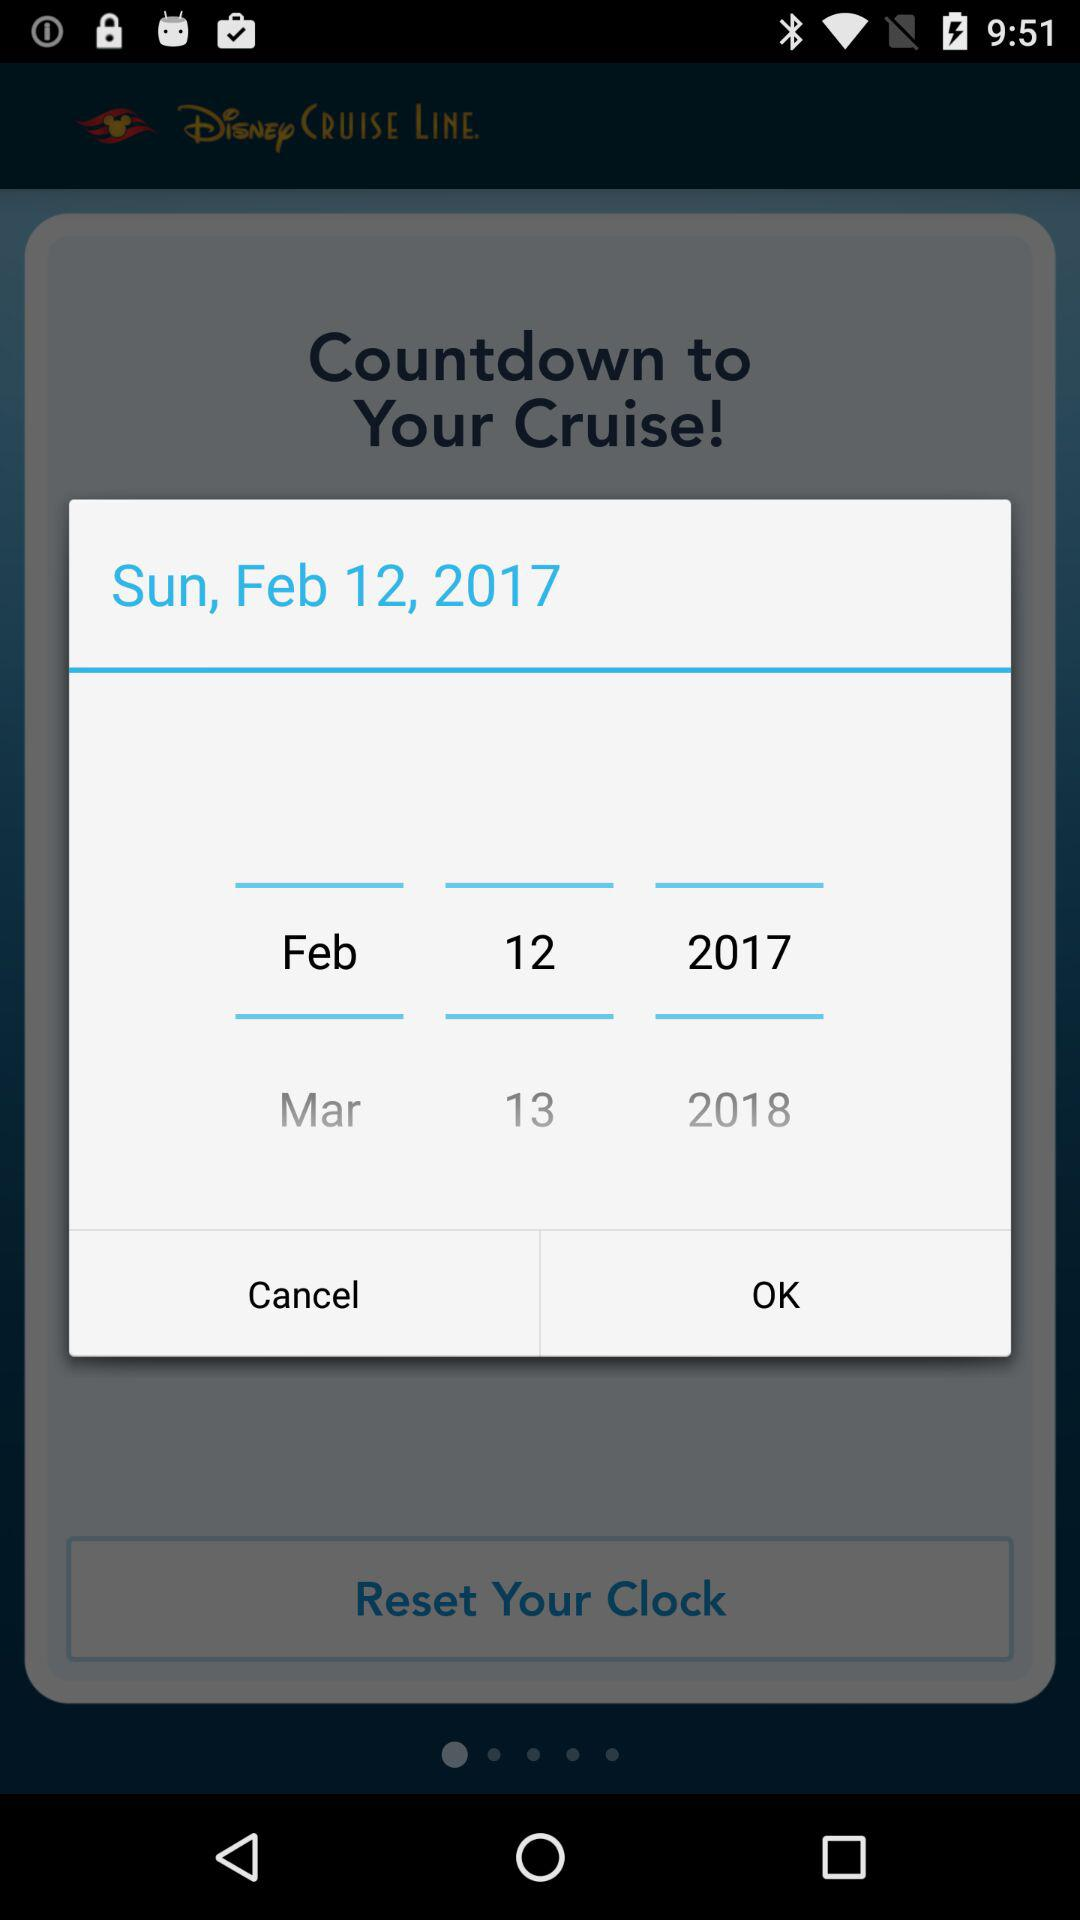What is the day on Feb 12, 2017? The day is Sunday. 